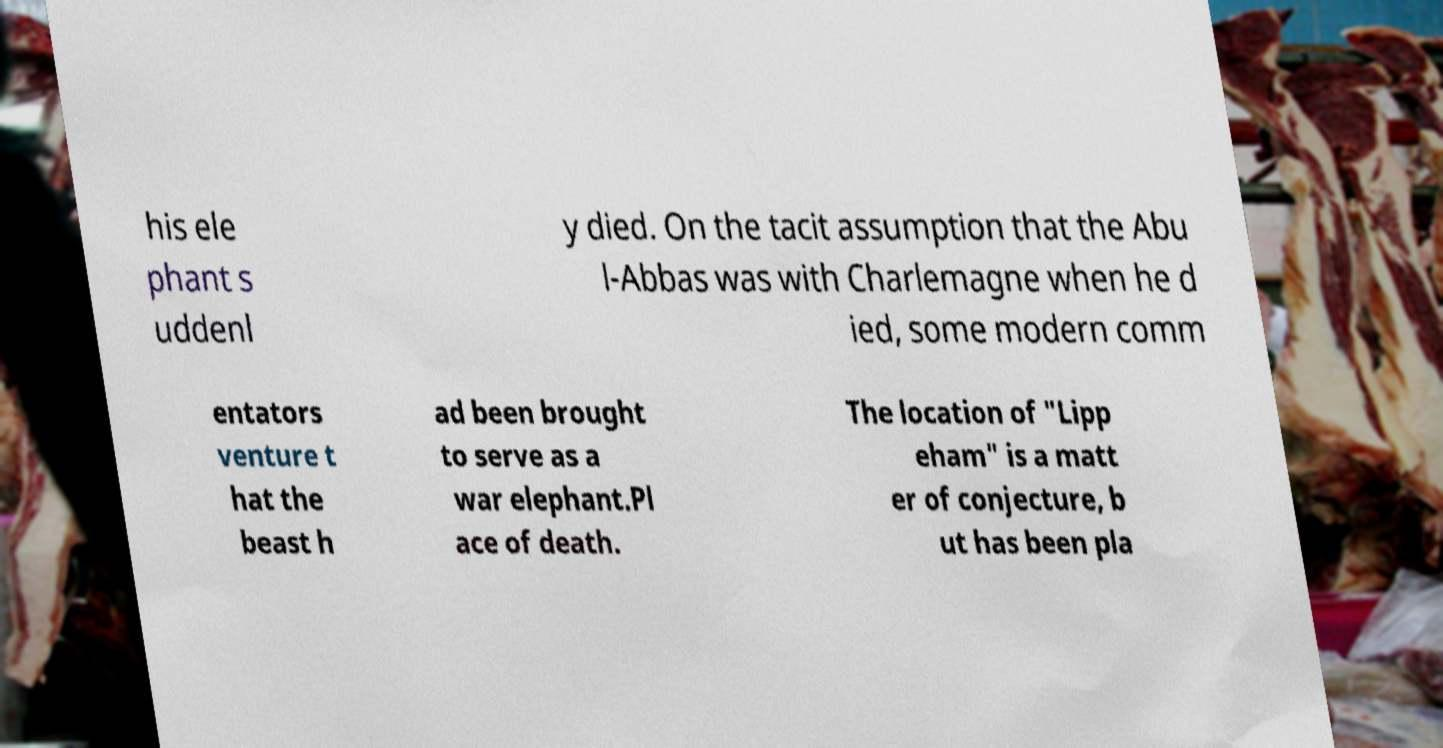Please read and relay the text visible in this image. What does it say? his ele phant s uddenl y died. On the tacit assumption that the Abu l-Abbas was with Charlemagne when he d ied, some modern comm entators venture t hat the beast h ad been brought to serve as a war elephant.Pl ace of death. The location of "Lipp eham" is a matt er of conjecture, b ut has been pla 